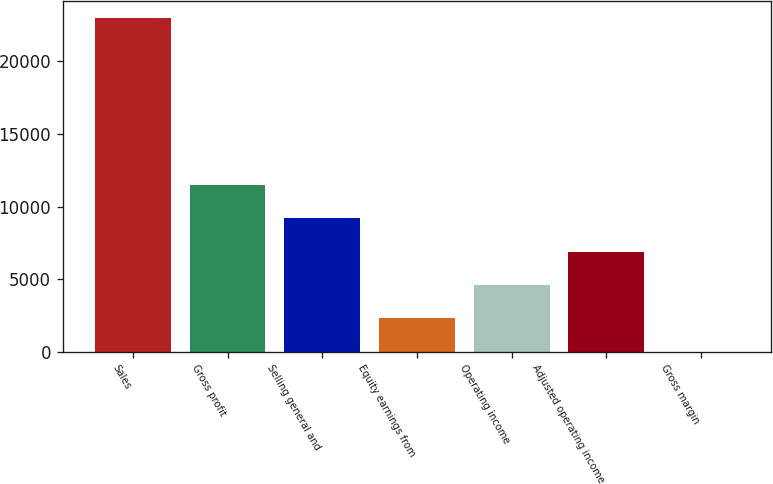Convert chart to OTSL. <chart><loc_0><loc_0><loc_500><loc_500><bar_chart><fcel>Sales<fcel>Gross profit<fcel>Selling general and<fcel>Equity earnings from<fcel>Operating income<fcel>Adjusted operating income<fcel>Gross margin<nl><fcel>23006<fcel>11507.5<fcel>9207.8<fcel>2308.7<fcel>4608.4<fcel>6908.1<fcel>9<nl></chart> 